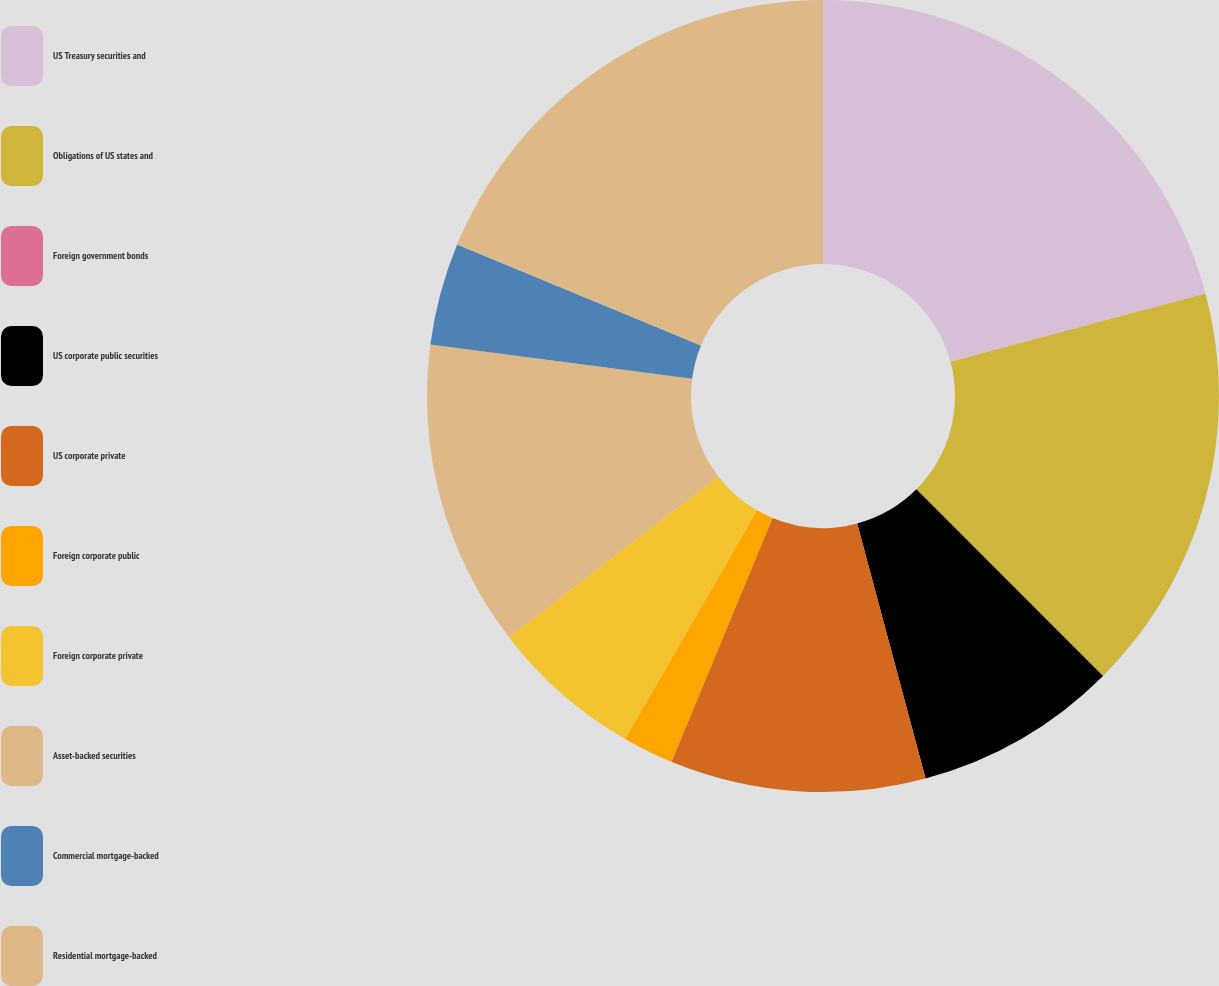<chart> <loc_0><loc_0><loc_500><loc_500><pie_chart><fcel>US Treasury securities and<fcel>Obligations of US states and<fcel>Foreign government bonds<fcel>US corporate public securities<fcel>US corporate private<fcel>Foreign corporate public<fcel>Foreign corporate private<fcel>Asset-backed securities<fcel>Commercial mortgage-backed<fcel>Residential mortgage-backed<nl><fcel>20.83%<fcel>16.67%<fcel>0.0%<fcel>8.33%<fcel>10.42%<fcel>2.08%<fcel>6.25%<fcel>12.5%<fcel>4.17%<fcel>18.75%<nl></chart> 